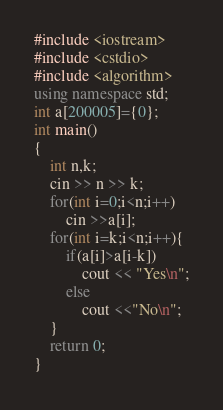Convert code to text. <code><loc_0><loc_0><loc_500><loc_500><_C++_>#include <iostream>
#include <cstdio>
#include <algorithm>
using namespace std;
int a[200005]={0};
int main()
{
    int n,k;
    cin >> n >> k;
    for(int i=0;i<n;i++)
        cin >>a[i];
    for(int i=k;i<n;i++){
        if(a[i]>a[i-k])
            cout << "Yes\n";
        else
            cout <<"No\n";
    }
    return 0;
}
</code> 